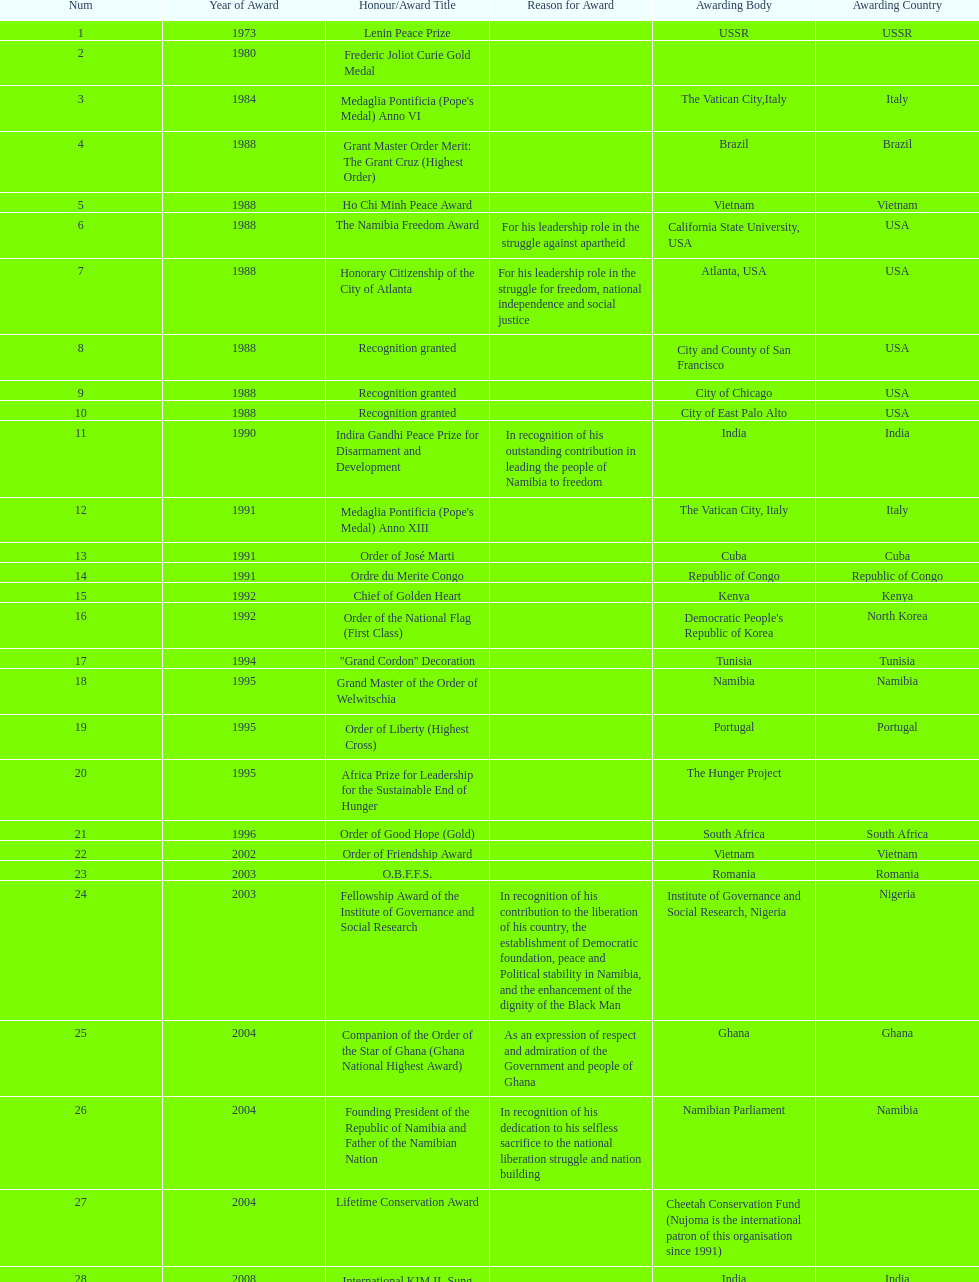What is the difference between the number of awards won in 1988 and the number of awards won in 1995? 4. 